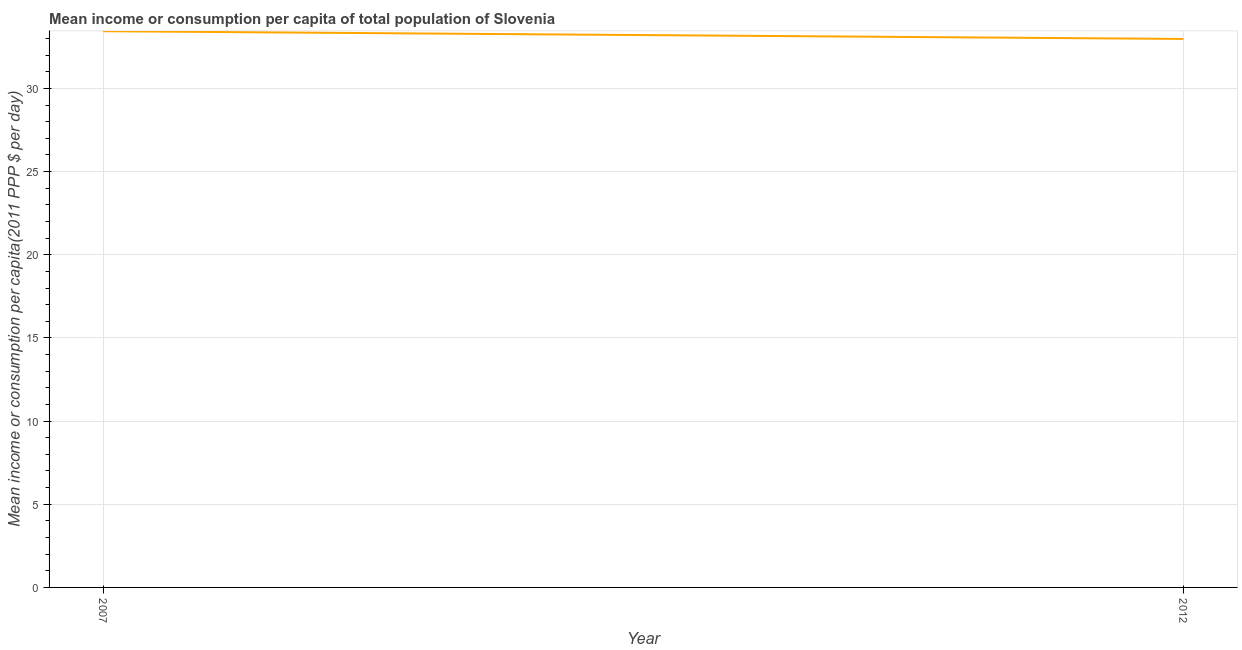What is the mean income or consumption in 2007?
Offer a terse response. 33.44. Across all years, what is the maximum mean income or consumption?
Give a very brief answer. 33.44. Across all years, what is the minimum mean income or consumption?
Provide a short and direct response. 32.97. In which year was the mean income or consumption minimum?
Keep it short and to the point. 2012. What is the sum of the mean income or consumption?
Keep it short and to the point. 66.41. What is the difference between the mean income or consumption in 2007 and 2012?
Provide a short and direct response. 0.47. What is the average mean income or consumption per year?
Provide a succinct answer. 33.21. What is the median mean income or consumption?
Offer a very short reply. 33.21. In how many years, is the mean income or consumption greater than 23 $?
Ensure brevity in your answer.  2. Do a majority of the years between 2012 and 2007 (inclusive) have mean income or consumption greater than 9 $?
Make the answer very short. No. What is the ratio of the mean income or consumption in 2007 to that in 2012?
Offer a terse response. 1.01. In how many years, is the mean income or consumption greater than the average mean income or consumption taken over all years?
Keep it short and to the point. 1. How many lines are there?
Your response must be concise. 1. What is the title of the graph?
Provide a short and direct response. Mean income or consumption per capita of total population of Slovenia. What is the label or title of the X-axis?
Make the answer very short. Year. What is the label or title of the Y-axis?
Your answer should be compact. Mean income or consumption per capita(2011 PPP $ per day). What is the Mean income or consumption per capita(2011 PPP $ per day) in 2007?
Your response must be concise. 33.44. What is the Mean income or consumption per capita(2011 PPP $ per day) of 2012?
Your answer should be very brief. 32.97. What is the difference between the Mean income or consumption per capita(2011 PPP $ per day) in 2007 and 2012?
Offer a terse response. 0.47. What is the ratio of the Mean income or consumption per capita(2011 PPP $ per day) in 2007 to that in 2012?
Keep it short and to the point. 1.01. 